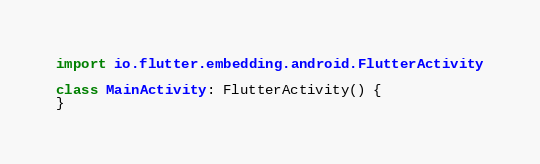Convert code to text. <code><loc_0><loc_0><loc_500><loc_500><_Kotlin_>
import io.flutter.embedding.android.FlutterActivity

class MainActivity: FlutterActivity() {
}
</code> 